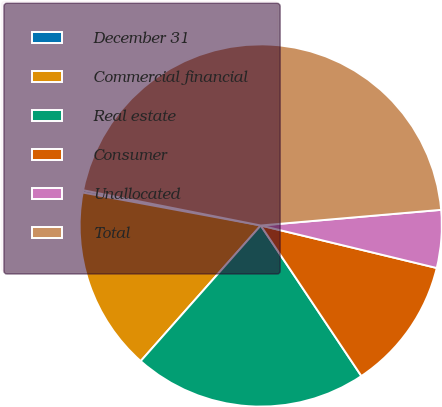<chart> <loc_0><loc_0><loc_500><loc_500><pie_chart><fcel>December 31<fcel>Commercial financial<fcel>Real estate<fcel>Consumer<fcel>Unallocated<fcel>Total<nl><fcel>0.21%<fcel>16.38%<fcel>20.91%<fcel>11.85%<fcel>5.15%<fcel>45.5%<nl></chart> 